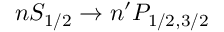<formula> <loc_0><loc_0><loc_500><loc_500>{ n S _ { 1 / 2 } } \rightarrow n ^ { \prime } P _ { 1 / 2 , 3 / 2 }</formula> 